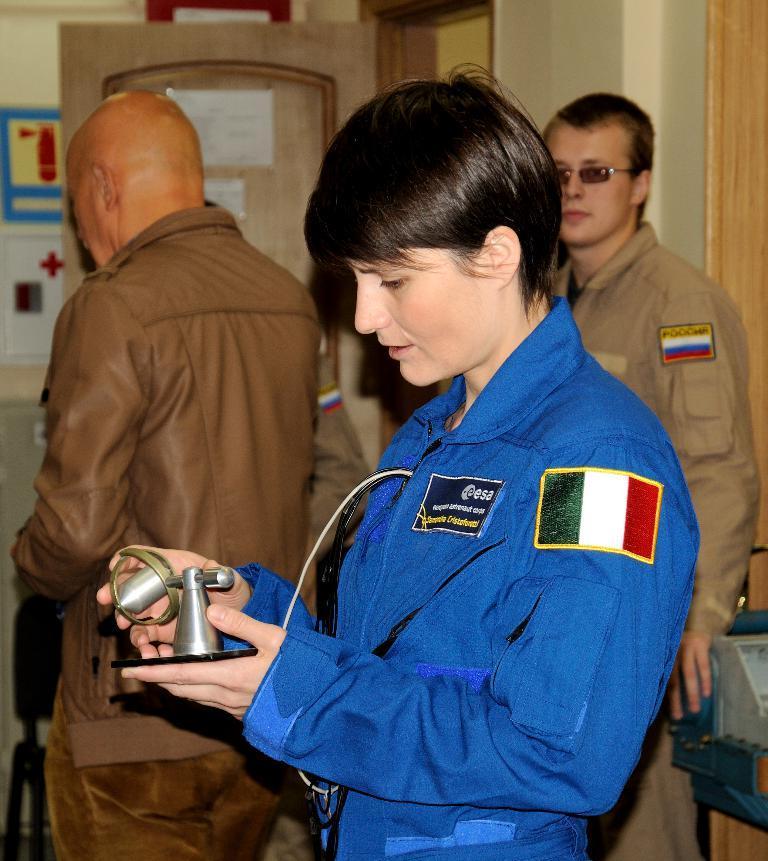In one or two sentences, can you explain what this image depicts? In this image there are two men standing, there is a man standing and holding an object, there is an object towards the right of the image, there is a wooden object towards the right of the image, there is wall towards the top of the image, there is a door, there are papers on the door, there is a wall towards the left of the image, there are objects on the wall, there is an object towards the bottom of the image. 